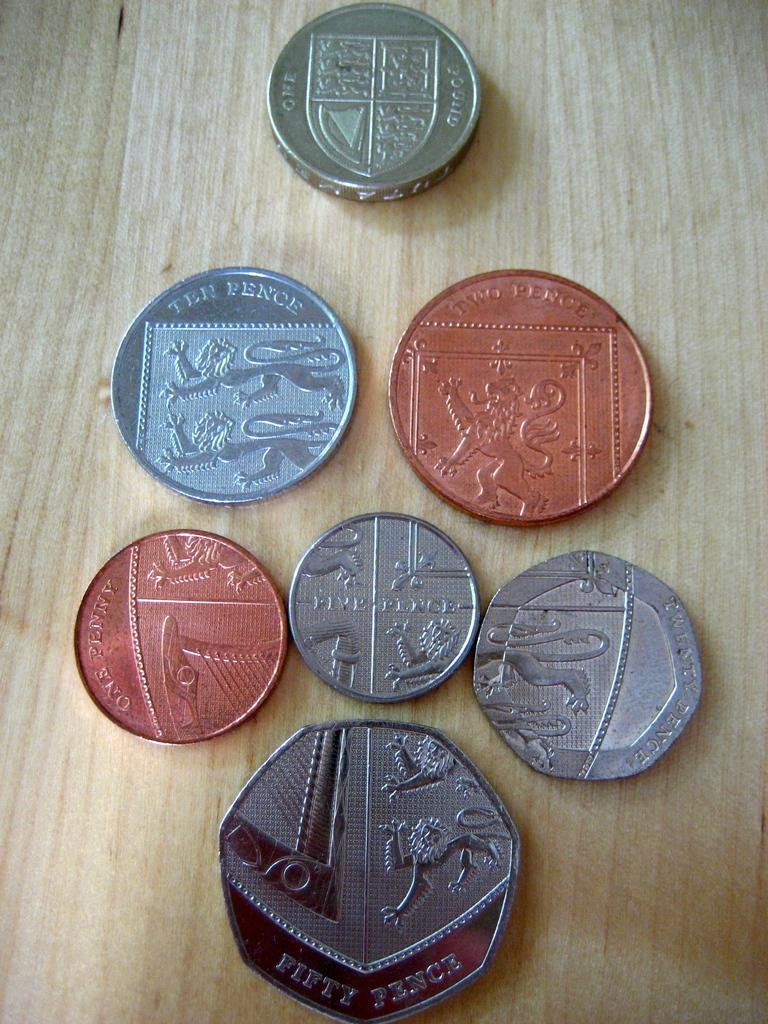<image>
Render a clear and concise summary of the photo. a selection of UK coins with a fifty pence at the bottom. 